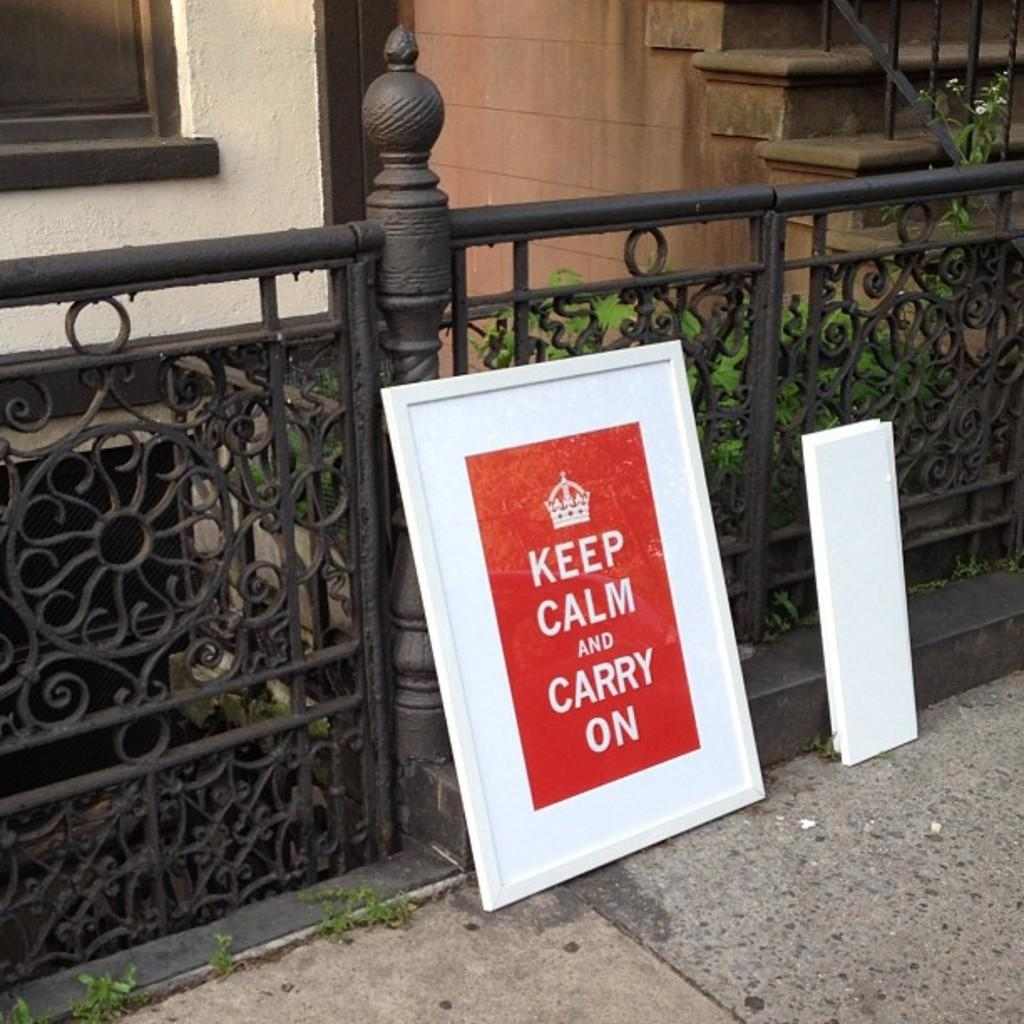What is the color of the photo frame in the image? The photo frame in the image is red and white. Where is the photo frame located? The photo frame is at a metal grill pipe. What can be seen in the background of the image? There are steps and a yellow color wall visible in the background of the image. What hobbies do the people in the photo frame enjoy? There is no information about the people in the photo frame or their hobbies in the image. 